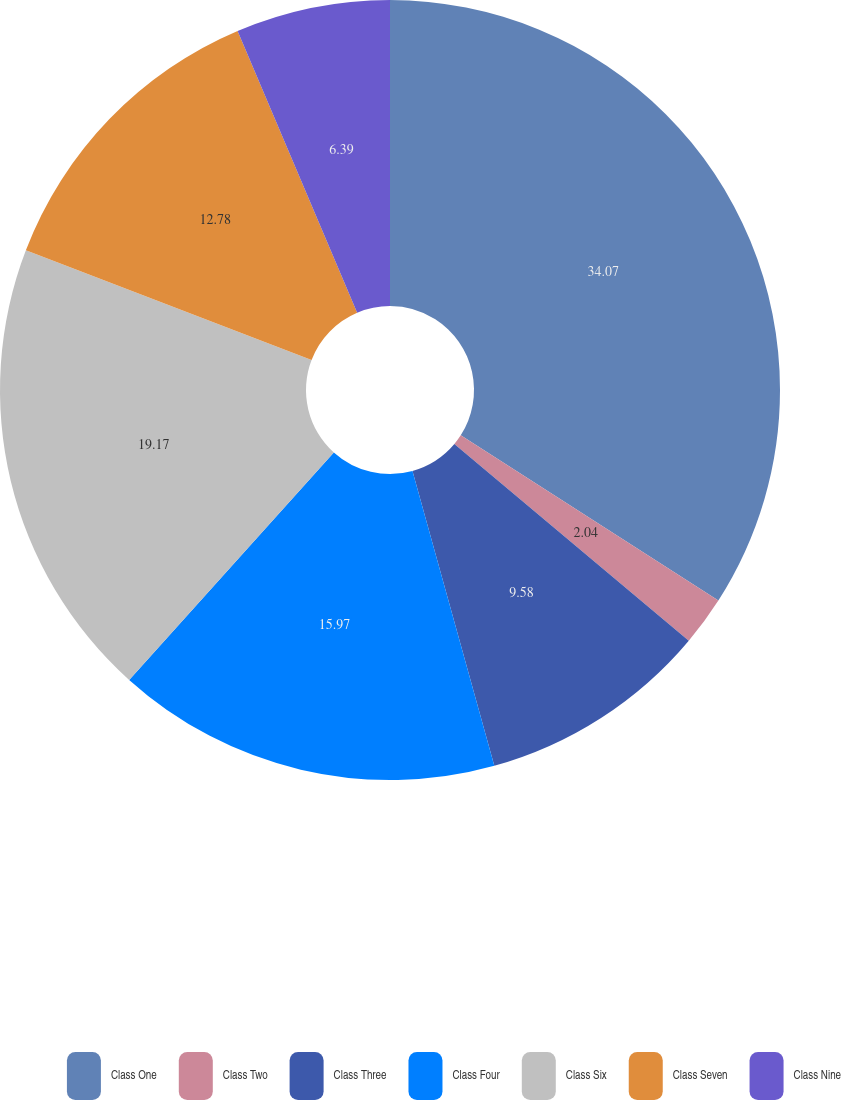<chart> <loc_0><loc_0><loc_500><loc_500><pie_chart><fcel>Class One<fcel>Class Two<fcel>Class Three<fcel>Class Four<fcel>Class Six<fcel>Class Seven<fcel>Class Nine<nl><fcel>34.07%<fcel>2.04%<fcel>9.58%<fcel>15.97%<fcel>19.17%<fcel>12.78%<fcel>6.39%<nl></chart> 